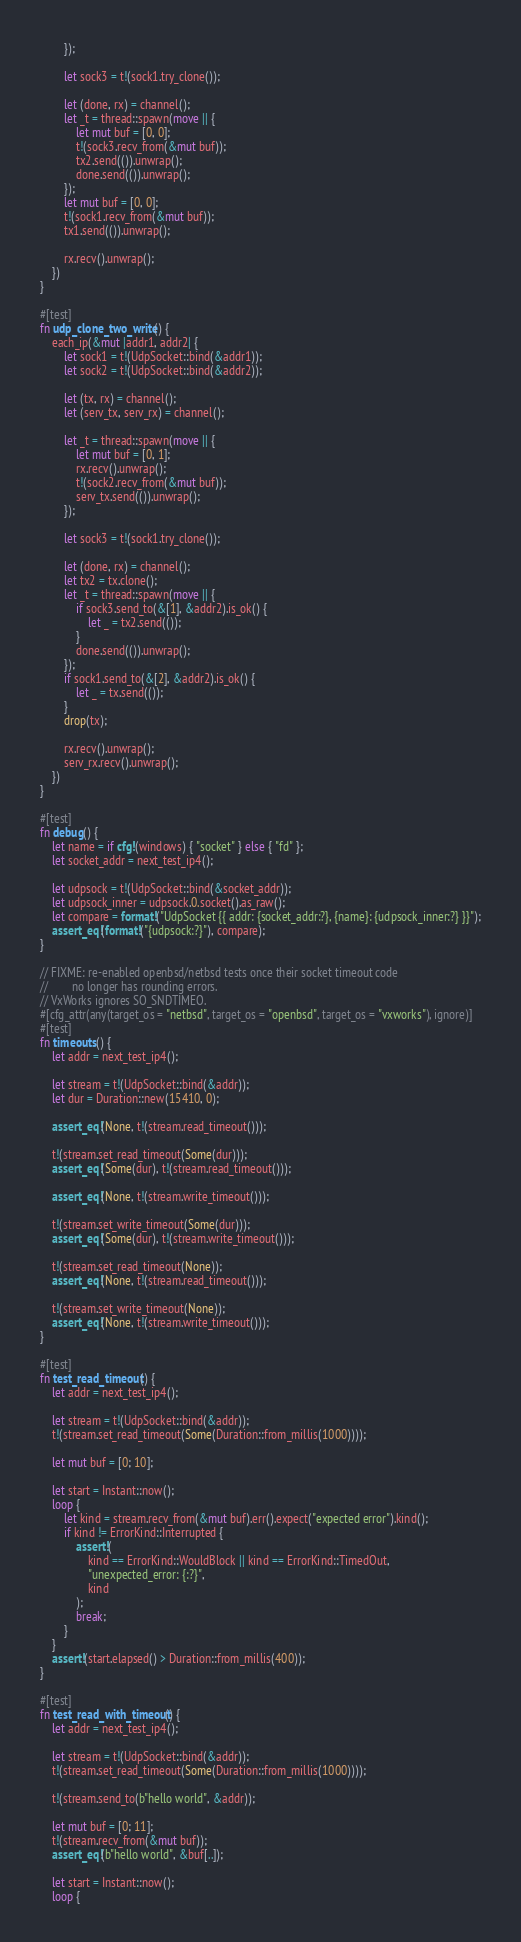<code> <loc_0><loc_0><loc_500><loc_500><_Rust_>        });

        let sock3 = t!(sock1.try_clone());

        let (done, rx) = channel();
        let _t = thread::spawn(move || {
            let mut buf = [0, 0];
            t!(sock3.recv_from(&mut buf));
            tx2.send(()).unwrap();
            done.send(()).unwrap();
        });
        let mut buf = [0, 0];
        t!(sock1.recv_from(&mut buf));
        tx1.send(()).unwrap();

        rx.recv().unwrap();
    })
}

#[test]
fn udp_clone_two_write() {
    each_ip(&mut |addr1, addr2| {
        let sock1 = t!(UdpSocket::bind(&addr1));
        let sock2 = t!(UdpSocket::bind(&addr2));

        let (tx, rx) = channel();
        let (serv_tx, serv_rx) = channel();

        let _t = thread::spawn(move || {
            let mut buf = [0, 1];
            rx.recv().unwrap();
            t!(sock2.recv_from(&mut buf));
            serv_tx.send(()).unwrap();
        });

        let sock3 = t!(sock1.try_clone());

        let (done, rx) = channel();
        let tx2 = tx.clone();
        let _t = thread::spawn(move || {
            if sock3.send_to(&[1], &addr2).is_ok() {
                let _ = tx2.send(());
            }
            done.send(()).unwrap();
        });
        if sock1.send_to(&[2], &addr2).is_ok() {
            let _ = tx.send(());
        }
        drop(tx);

        rx.recv().unwrap();
        serv_rx.recv().unwrap();
    })
}

#[test]
fn debug() {
    let name = if cfg!(windows) { "socket" } else { "fd" };
    let socket_addr = next_test_ip4();

    let udpsock = t!(UdpSocket::bind(&socket_addr));
    let udpsock_inner = udpsock.0.socket().as_raw();
    let compare = format!("UdpSocket {{ addr: {socket_addr:?}, {name}: {udpsock_inner:?} }}");
    assert_eq!(format!("{udpsock:?}"), compare);
}

// FIXME: re-enabled openbsd/netbsd tests once their socket timeout code
//        no longer has rounding errors.
// VxWorks ignores SO_SNDTIMEO.
#[cfg_attr(any(target_os = "netbsd", target_os = "openbsd", target_os = "vxworks"), ignore)]
#[test]
fn timeouts() {
    let addr = next_test_ip4();

    let stream = t!(UdpSocket::bind(&addr));
    let dur = Duration::new(15410, 0);

    assert_eq!(None, t!(stream.read_timeout()));

    t!(stream.set_read_timeout(Some(dur)));
    assert_eq!(Some(dur), t!(stream.read_timeout()));

    assert_eq!(None, t!(stream.write_timeout()));

    t!(stream.set_write_timeout(Some(dur)));
    assert_eq!(Some(dur), t!(stream.write_timeout()));

    t!(stream.set_read_timeout(None));
    assert_eq!(None, t!(stream.read_timeout()));

    t!(stream.set_write_timeout(None));
    assert_eq!(None, t!(stream.write_timeout()));
}

#[test]
fn test_read_timeout() {
    let addr = next_test_ip4();

    let stream = t!(UdpSocket::bind(&addr));
    t!(stream.set_read_timeout(Some(Duration::from_millis(1000))));

    let mut buf = [0; 10];

    let start = Instant::now();
    loop {
        let kind = stream.recv_from(&mut buf).err().expect("expected error").kind();
        if kind != ErrorKind::Interrupted {
            assert!(
                kind == ErrorKind::WouldBlock || kind == ErrorKind::TimedOut,
                "unexpected_error: {:?}",
                kind
            );
            break;
        }
    }
    assert!(start.elapsed() > Duration::from_millis(400));
}

#[test]
fn test_read_with_timeout() {
    let addr = next_test_ip4();

    let stream = t!(UdpSocket::bind(&addr));
    t!(stream.set_read_timeout(Some(Duration::from_millis(1000))));

    t!(stream.send_to(b"hello world", &addr));

    let mut buf = [0; 11];
    t!(stream.recv_from(&mut buf));
    assert_eq!(b"hello world", &buf[..]);

    let start = Instant::now();
    loop {</code> 